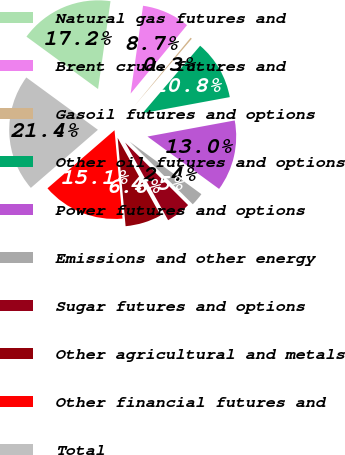Convert chart. <chart><loc_0><loc_0><loc_500><loc_500><pie_chart><fcel>Natural gas futures and<fcel>Brent crude futures and<fcel>Gasoil futures and options<fcel>Other oil futures and options<fcel>Power futures and options<fcel>Emissions and other energy<fcel>Sugar futures and options<fcel>Other agricultural and metals<fcel>Other financial futures and<fcel>Total<nl><fcel>17.19%<fcel>8.73%<fcel>0.28%<fcel>10.85%<fcel>12.96%<fcel>2.39%<fcel>4.51%<fcel>6.62%<fcel>15.07%<fcel>21.41%<nl></chart> 